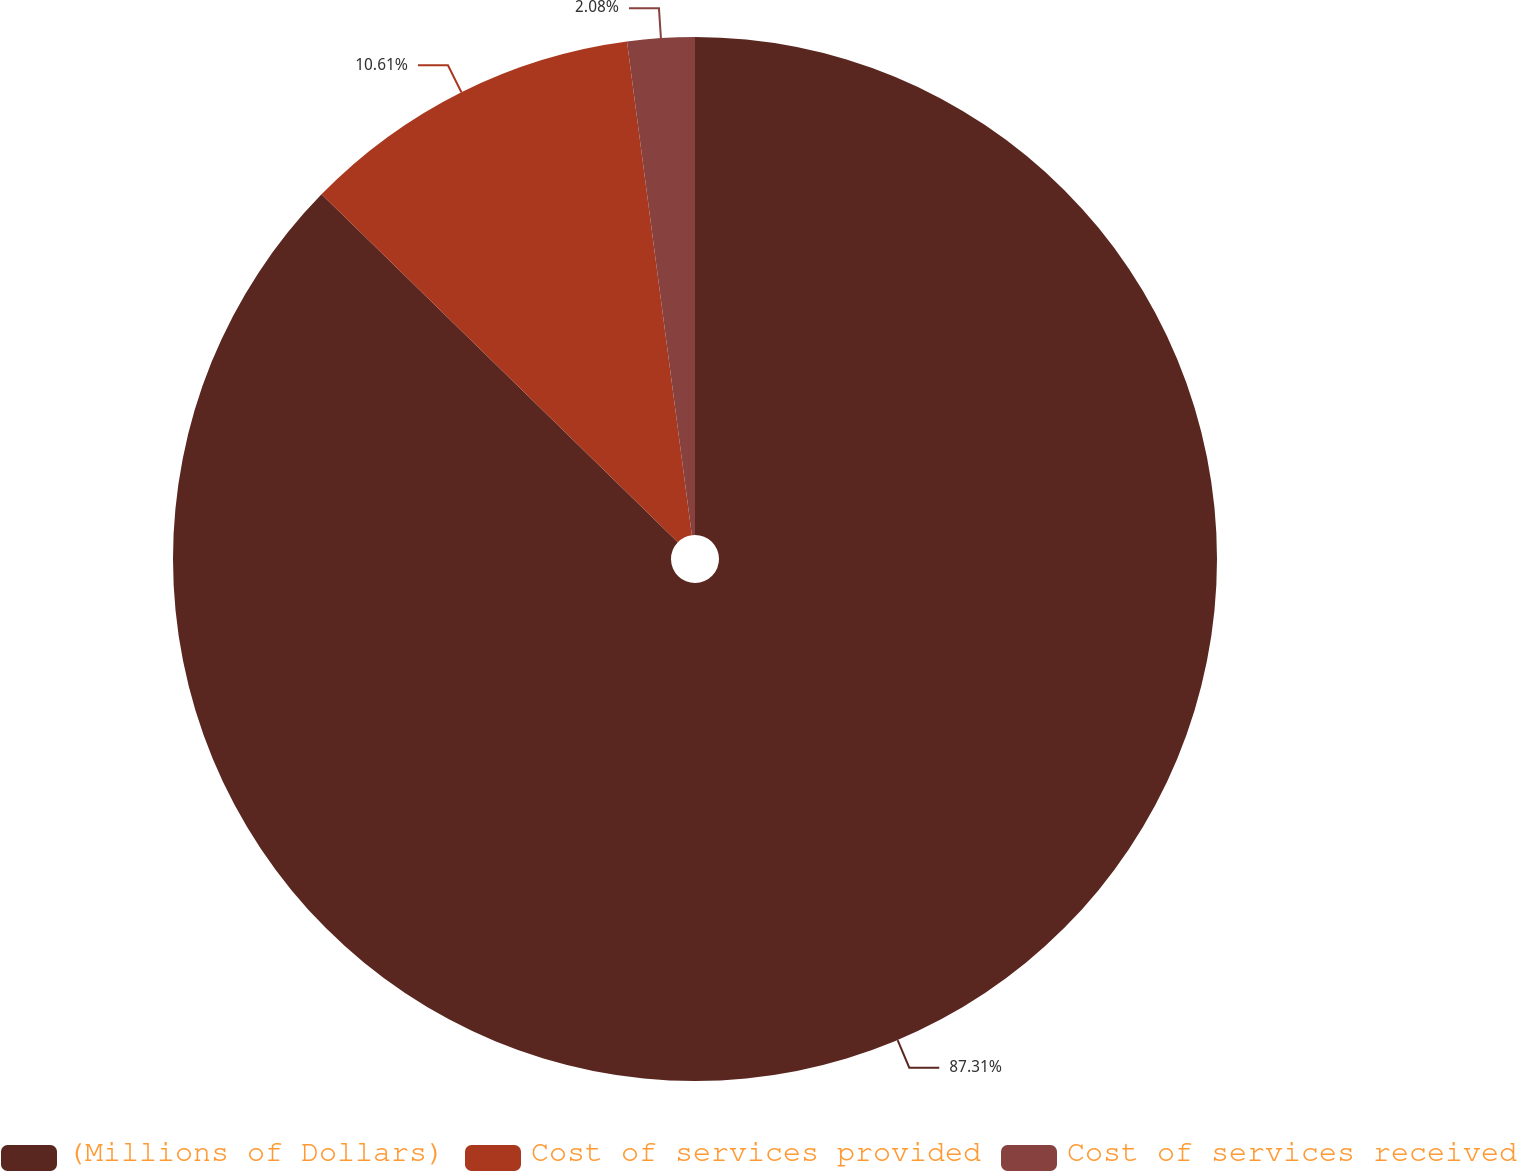Convert chart. <chart><loc_0><loc_0><loc_500><loc_500><pie_chart><fcel>(Millions of Dollars)<fcel>Cost of services provided<fcel>Cost of services received<nl><fcel>87.31%<fcel>10.61%<fcel>2.08%<nl></chart> 